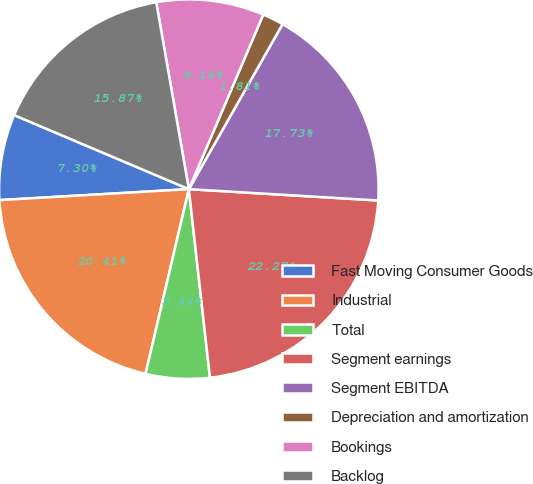Convert chart. <chart><loc_0><loc_0><loc_500><loc_500><pie_chart><fcel>Fast Moving Consumer Goods<fcel>Industrial<fcel>Total<fcel>Segment earnings<fcel>Segment EBITDA<fcel>Depreciation and amortization<fcel>Bookings<fcel>Backlog<nl><fcel>7.3%<fcel>20.41%<fcel>5.44%<fcel>22.27%<fcel>17.73%<fcel>1.81%<fcel>9.16%<fcel>15.87%<nl></chart> 